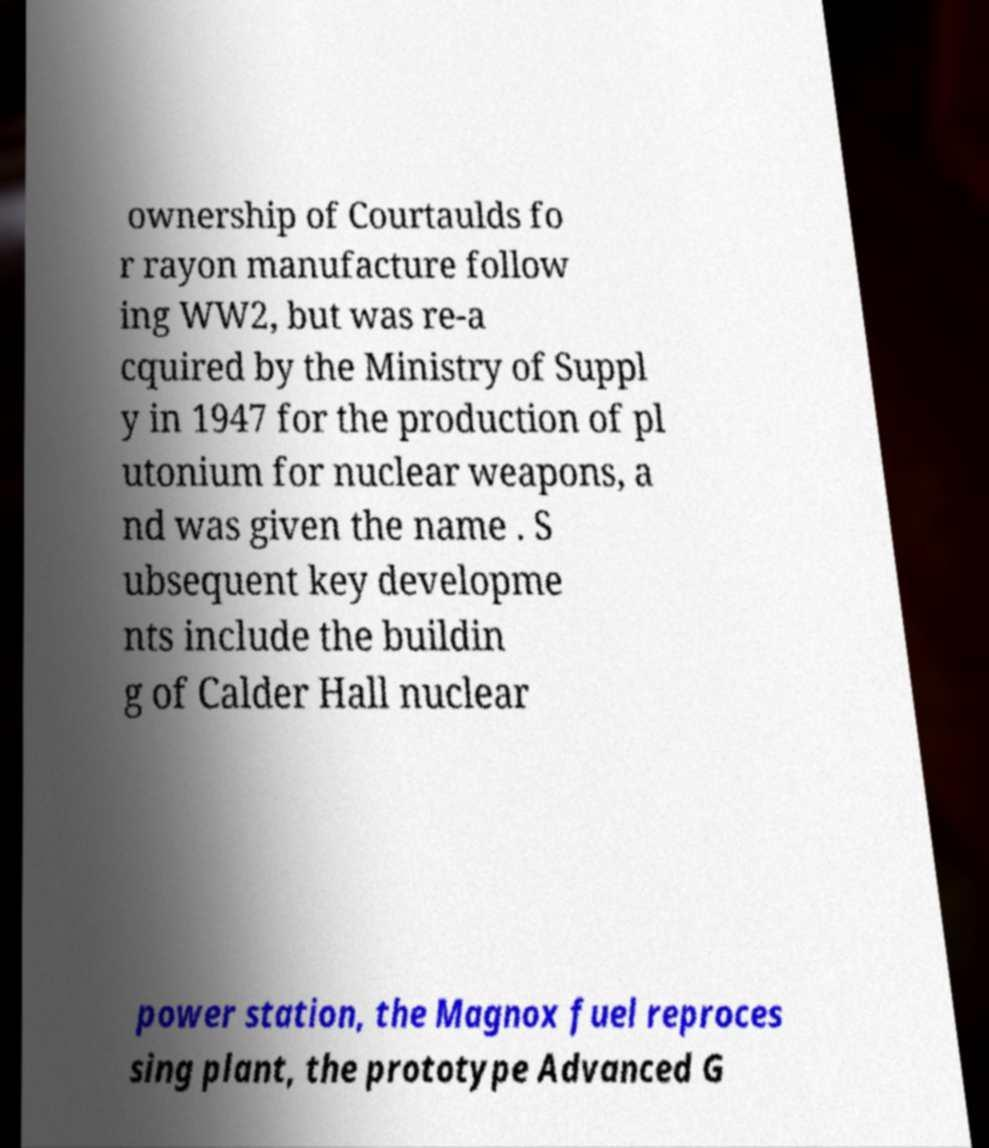What messages or text are displayed in this image? I need them in a readable, typed format. ownership of Courtaulds fo r rayon manufacture follow ing WW2, but was re-a cquired by the Ministry of Suppl y in 1947 for the production of pl utonium for nuclear weapons, a nd was given the name . S ubsequent key developme nts include the buildin g of Calder Hall nuclear power station, the Magnox fuel reproces sing plant, the prototype Advanced G 